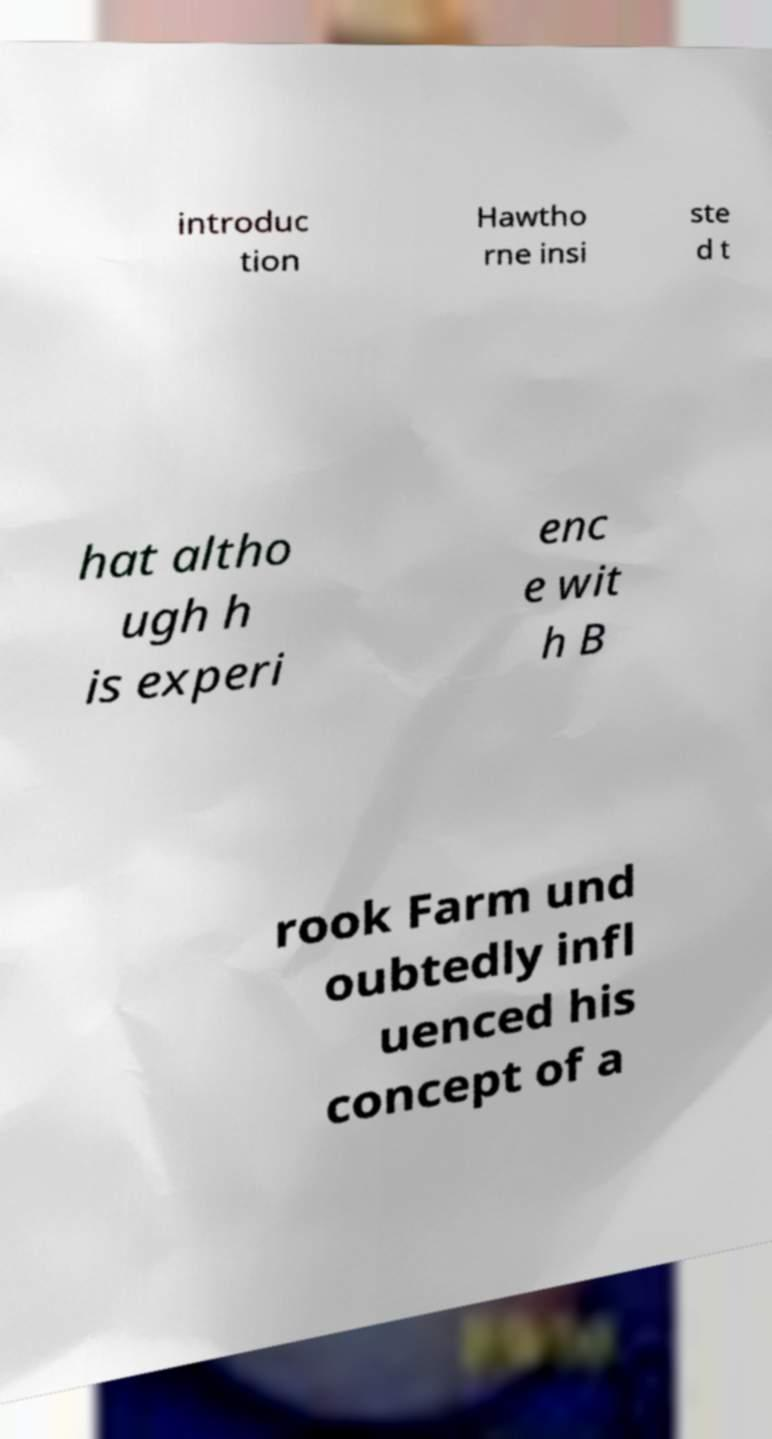Could you assist in decoding the text presented in this image and type it out clearly? introduc tion Hawtho rne insi ste d t hat altho ugh h is experi enc e wit h B rook Farm und oubtedly infl uenced his concept of a 